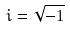Convert formula to latex. <formula><loc_0><loc_0><loc_500><loc_500>i = \sqrt { - 1 }</formula> 